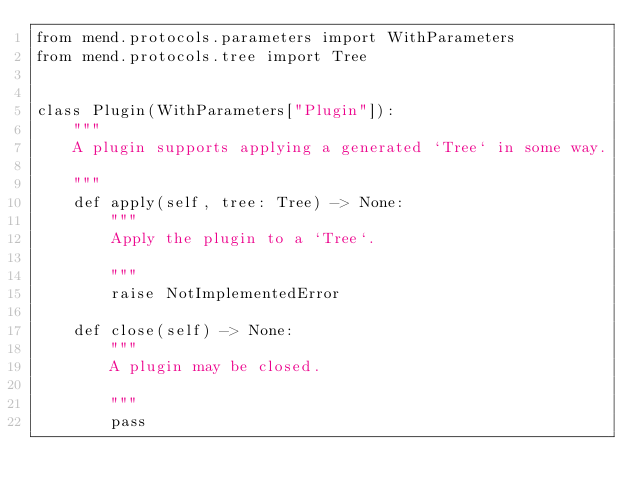Convert code to text. <code><loc_0><loc_0><loc_500><loc_500><_Python_>from mend.protocols.parameters import WithParameters
from mend.protocols.tree import Tree


class Plugin(WithParameters["Plugin"]):
    """
    A plugin supports applying a generated `Tree` in some way.

    """
    def apply(self, tree: Tree) -> None:
        """
        Apply the plugin to a `Tree`.

        """
        raise NotImplementedError

    def close(self) -> None:
        """
        A plugin may be closed.

        """
        pass
</code> 